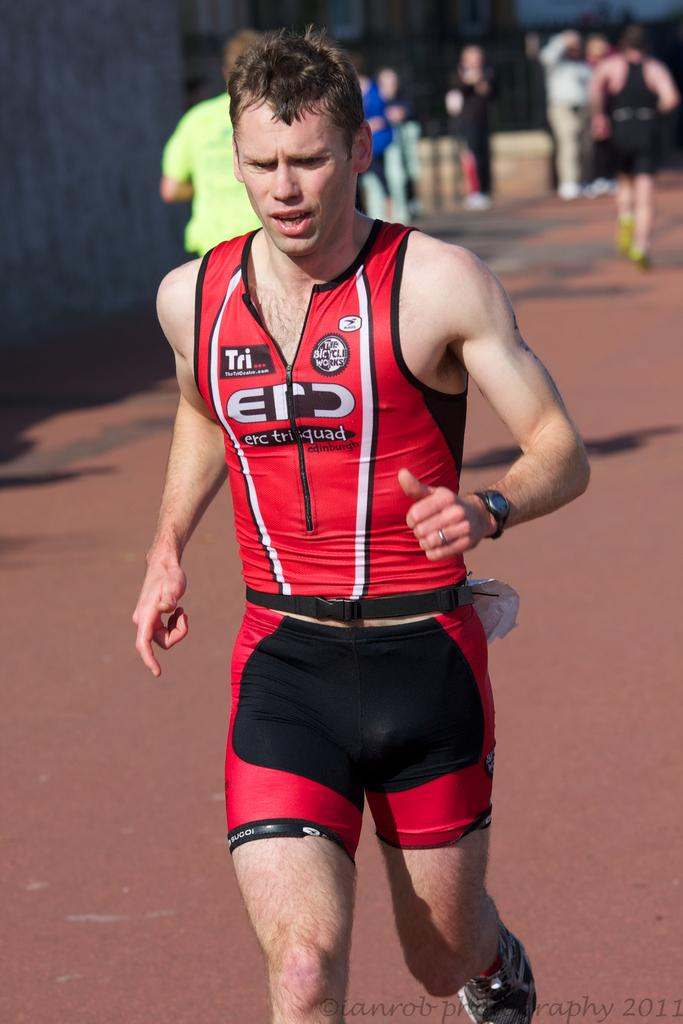<image>
Present a compact description of the photo's key features. the word tri is on the shirt of a man 